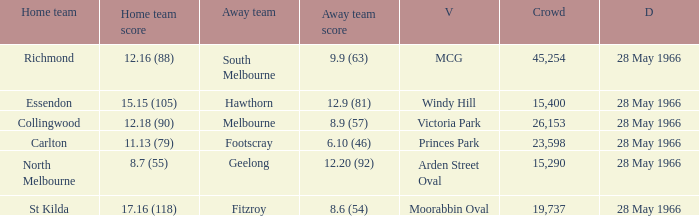Which Crowd has an Away team score of 8.6 (54)? 19737.0. 